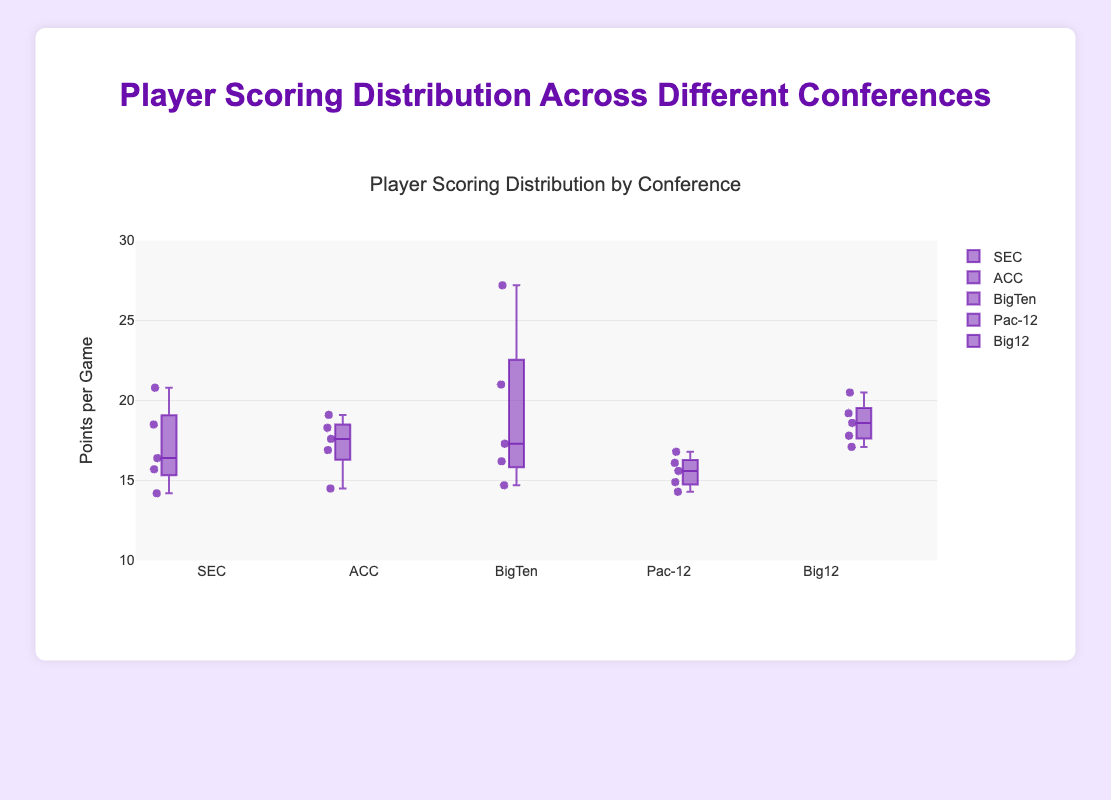What is the range of points per game for players in the SEC conference? The range is the difference between the maximum and minimum values. The maximum points per game in the SEC is 20.8 and the minimum is 14.2. So, the range is 20.8 - 14.2 = 6.6
Answer: 6.6 What is the median points per game for players in the Big 12 conference? The median is the middle value when the data points are ordered. For the Big 12 conference, the points are [17.1, 17.8, 18.6, 19.2, 20.5]. The middle value is 18.6.
Answer: 18.6 Which conference has the player with the highest points per game? We look for the highest individual value among all conferences. Caitlin Clark in the Big Ten has the highest points per game with 27.2.
Answer: Big Ten How does the median points per game of the ACC compare with the median of the Pac-12? Calculate the median for both conferences. For ACC: [14.5, 16.9, 17.6, 18.3, 19.1], the median is 17.6. For Pac-12: [14.3, 14.9, 15.6, 16.1, 16.8], the median is 15.6. The ACC's median is higher.
Answer: ACC's median is higher What is the interquartile range (IQR) for the SEC conference? IQR is the difference between the third quartile (Q3) and the first quartile (Q1). Ordered points for SEC: [14.2, 15.7, 16.4, 18.5, 20.8]. Q1 is 15.7, Q3 is 18.5, so IQR is 18.5 - 15.7 = 2.8
Answer: 2.8 Which conference has the smallest range in points per game? The range for each conference is calculated as the difference between the maximum and minimum points. The ranges are: SEC (6.6), ACC (4.6), Big Ten (12.5), Pac-12 (2.5), Big 12 (3.4). The conference with the smallest range is Pac-12.
Answer: Pac-12 What is the average points per game for players in the Big Ten conference? Sum the points and divide by the number of players. (27.2 + 21.0 + 16.2 + 17.3 + 14.7) / 5 = 96.4 / 5 = 19.28
Answer: 19.28 Compare the upper whiskers of the Big Ten and SEC conferences. Which one indicates a higher maximum points per game? The upper whisker ends at the maximum value. For Big Ten, the highest points per game is 27.2. For SEC, it's 20.8. Big Ten has a higher maximum.
Answer: Big Ten Which player from the ACC has the highest points per game? Among the ACC players, the highest points per game is 19.1 by Jewel Spear.
Answer: Jewel Spear 